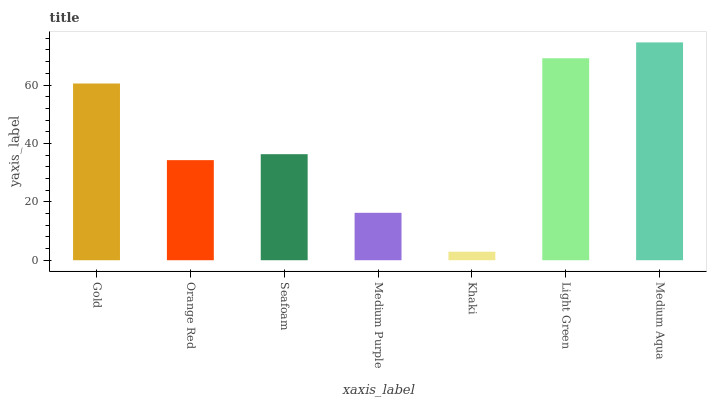Is Khaki the minimum?
Answer yes or no. Yes. Is Medium Aqua the maximum?
Answer yes or no. Yes. Is Orange Red the minimum?
Answer yes or no. No. Is Orange Red the maximum?
Answer yes or no. No. Is Gold greater than Orange Red?
Answer yes or no. Yes. Is Orange Red less than Gold?
Answer yes or no. Yes. Is Orange Red greater than Gold?
Answer yes or no. No. Is Gold less than Orange Red?
Answer yes or no. No. Is Seafoam the high median?
Answer yes or no. Yes. Is Seafoam the low median?
Answer yes or no. Yes. Is Orange Red the high median?
Answer yes or no. No. Is Gold the low median?
Answer yes or no. No. 